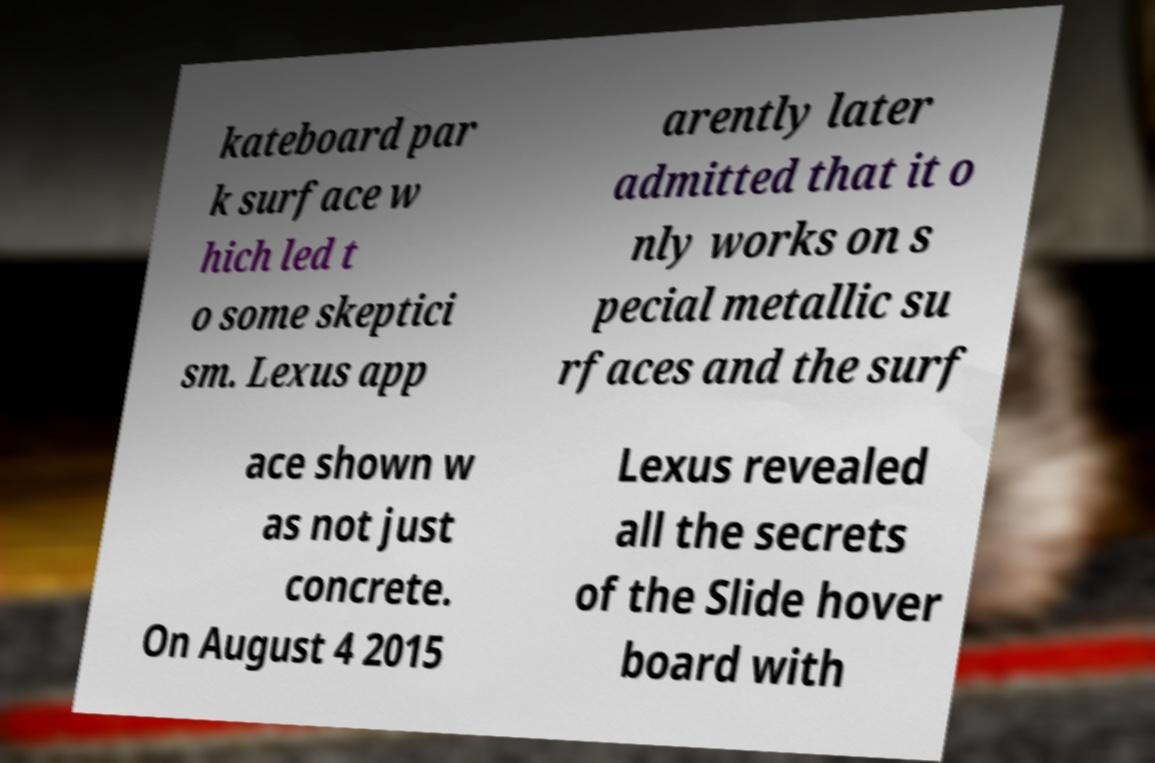What messages or text are displayed in this image? I need them in a readable, typed format. kateboard par k surface w hich led t o some skeptici sm. Lexus app arently later admitted that it o nly works on s pecial metallic su rfaces and the surf ace shown w as not just concrete. On August 4 2015 Lexus revealed all the secrets of the Slide hover board with 